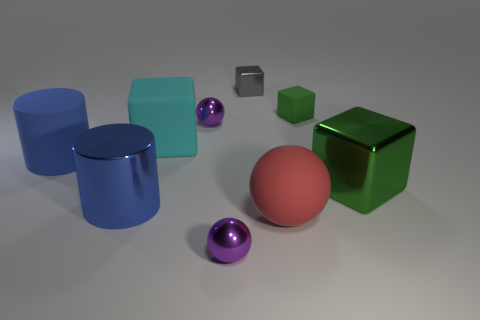Subtract 2 cubes. How many cubes are left? 2 Subtract all blue cubes. Subtract all cyan balls. How many cubes are left? 4 Subtract all cylinders. How many objects are left? 7 Subtract all metal balls. Subtract all rubber things. How many objects are left? 3 Add 2 gray metal cubes. How many gray metal cubes are left? 3 Add 8 shiny cylinders. How many shiny cylinders exist? 9 Subtract 0 gray balls. How many objects are left? 9 